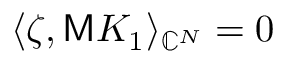<formula> <loc_0><loc_0><loc_500><loc_500>\langle \zeta , M K _ { 1 } \rangle _ { \mathbb { C } ^ { N } } = 0</formula> 